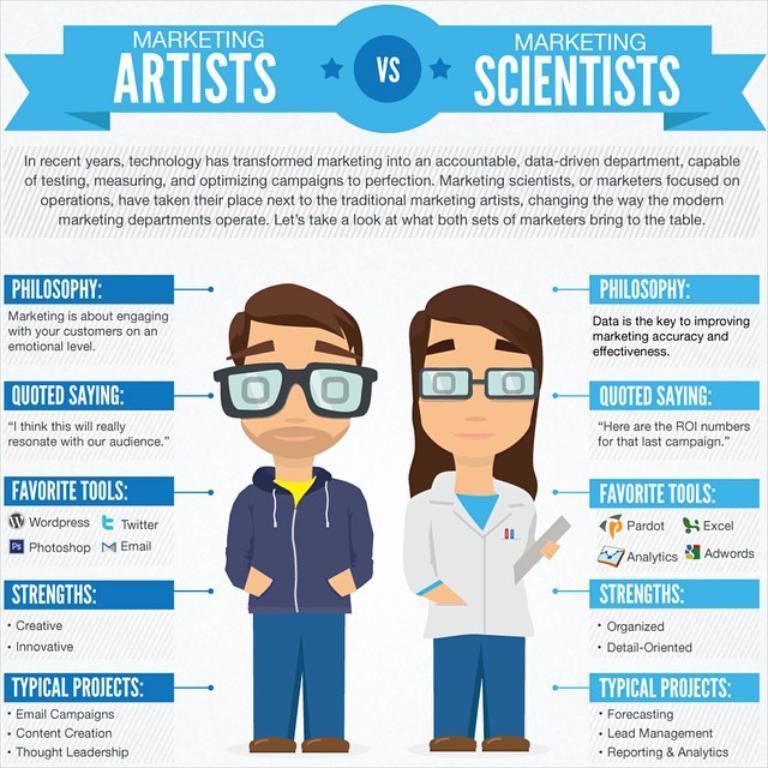In one or two sentences, can you explain what this image depicts? This is a poster. In the center of the image we can see two people are standing and wearing spectacles and a lady is holding a paper. In the background of the image we can see the text. 